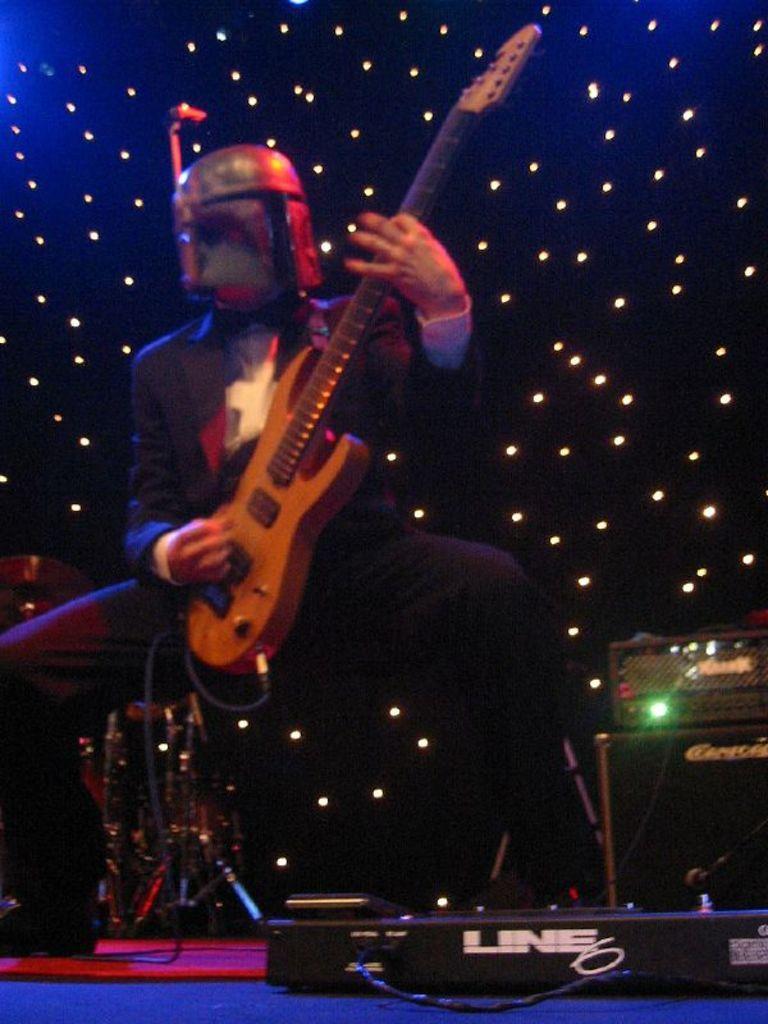How would you summarize this image in a sentence or two? A man wearing a helmet is holding a guitar and playing. In the background there is lights. In the front there is a musical instrument. 